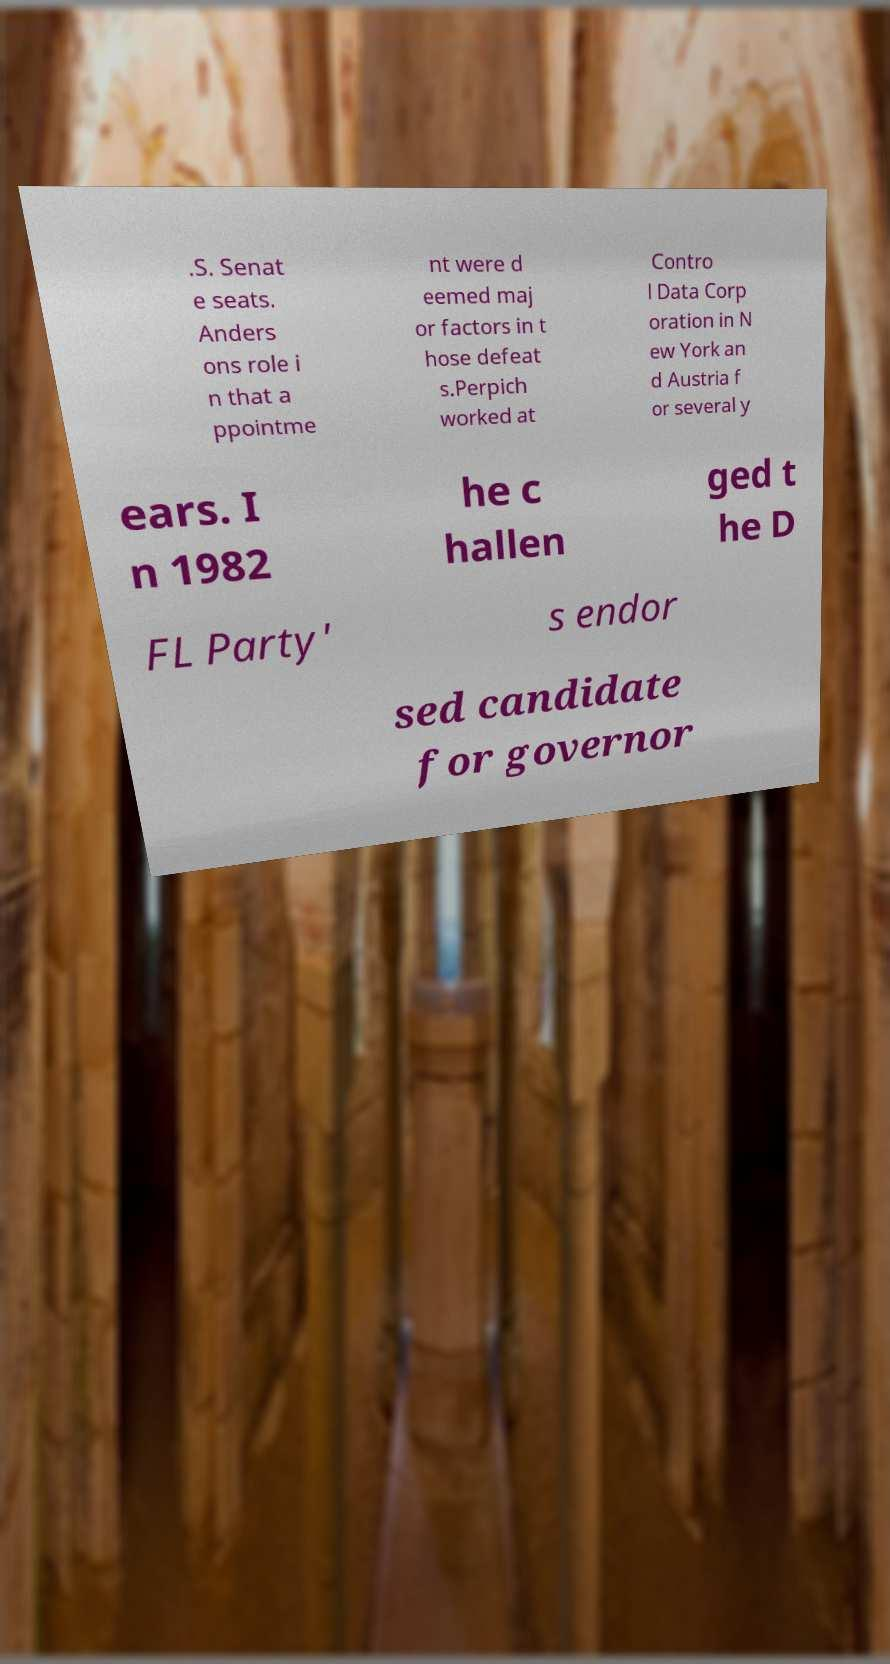Could you assist in decoding the text presented in this image and type it out clearly? .S. Senat e seats. Anders ons role i n that a ppointme nt were d eemed maj or factors in t hose defeat s.Perpich worked at Contro l Data Corp oration in N ew York an d Austria f or several y ears. I n 1982 he c hallen ged t he D FL Party' s endor sed candidate for governor 